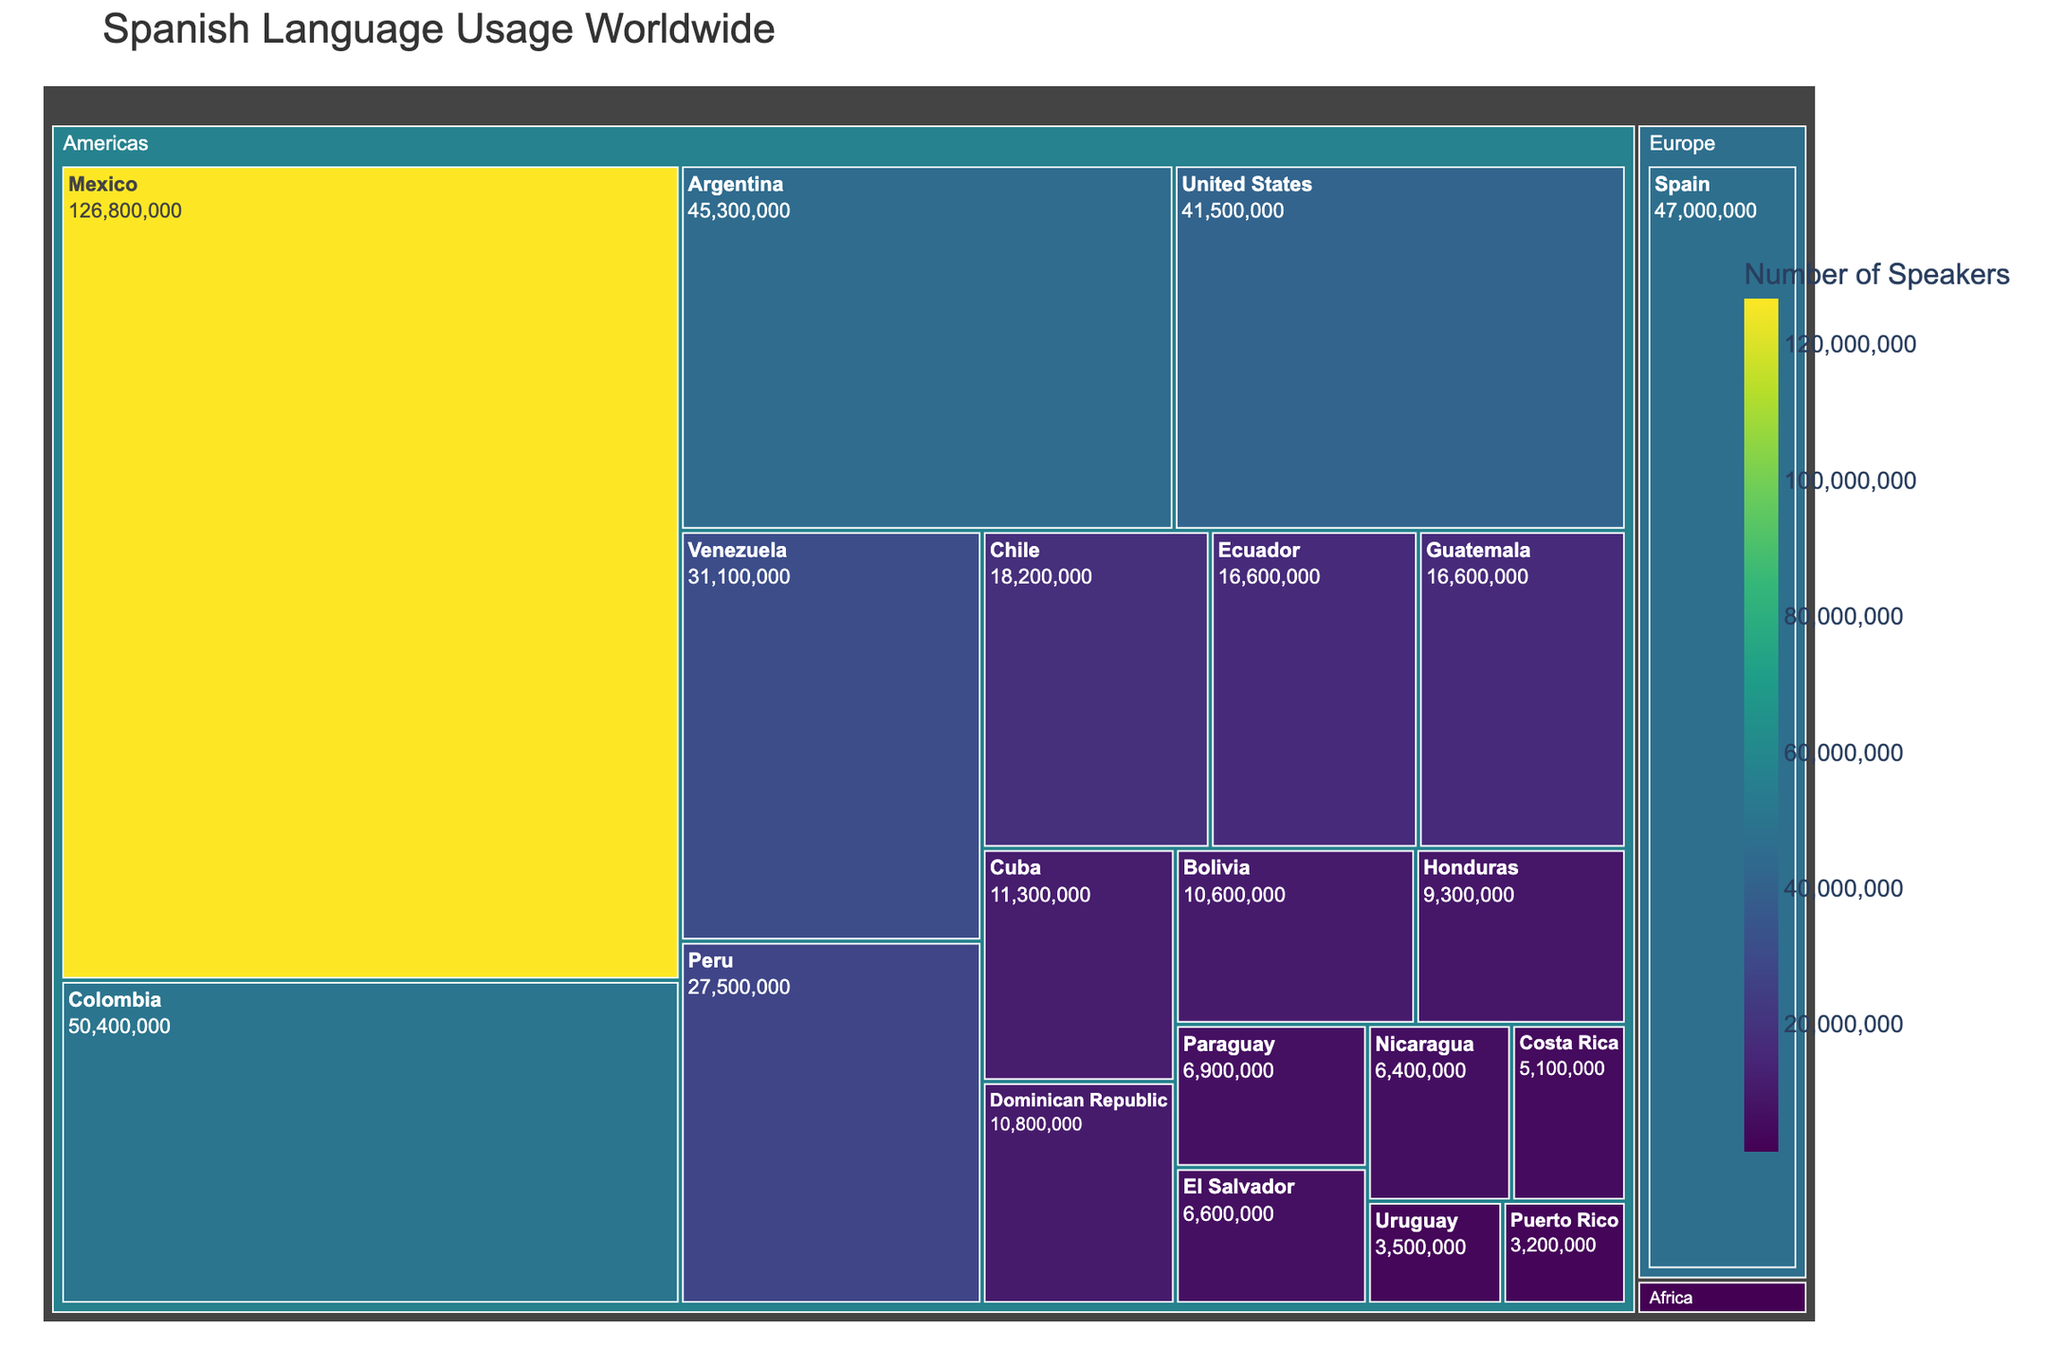What's the title of the treemap? The title is displayed at the top of the treemap and reads "Spanish Language Usage Worldwide".
Answer: Spanish Language Usage Worldwide Which country has the largest number of Spanish speakers? The largest section in the treemap corresponds to Mexico, indicating it has the most Spanish speakers.
Answer: Mexico Is Spain the country with the most Spanish speakers in Europe? Spain is the only country from Europe listed in the treemap, and it has the most Spanish speakers in Europe based on the figure.
Answer: Yes How many countries in the Americas have Spanish speakers? The treemap sections labeled under the Americas show 19 individual countries with Spanish speakers.
Answer: 19 Does the United States have more Spanish speakers than Peru and Chile combined? According to the treemap, the United States has 41,500,000 Spanish speakers. Peru has 27,500,000 and Chile 18,200,000. Combining Peru and Chile's speakers equals 45,700,000. Thus, the U.S. has fewer Spanish speakers.
Answer: No Which region has the least number of countries represented in the treemap? The regions are labeled, and Africa shows only one country—Equatorial Guinea—making it the region with the least representation.
Answer: Africa What color scale is used in the treemap to represent the number of speakers? By observing the legend, we can see that the "Viridis" color scale represents the number of speakers.
Answer: Viridis Among Spain, Colombia, and Argentina, which country has the second-highest number of Spanish speakers? Checking the sizes and numbers, Colombia has 50,400,000 speakers, Argentina has 45,300,000, and Spain has 47,000,000. Hence, Spain is second.
Answer: Spain Is the total number of Spanish speakers in Equatorial Guinea more than 1 million? The treemap shows Equatorial Guinea has 1,400,000 speakers, which is more than 1 million.
Answer: Yes What is the total number of Spanish speakers in the figures if we sum the major regions? Summing the speakers: Americas has (126,800,000 from Mexico + 50,400,000 from Colombia + various totals), Europe (47,000,000 from Spain), and Africa (1,400,000 from Equatorial Guinea). Completing the addition, we calculate the total.
Answer: (Calculation needed) 